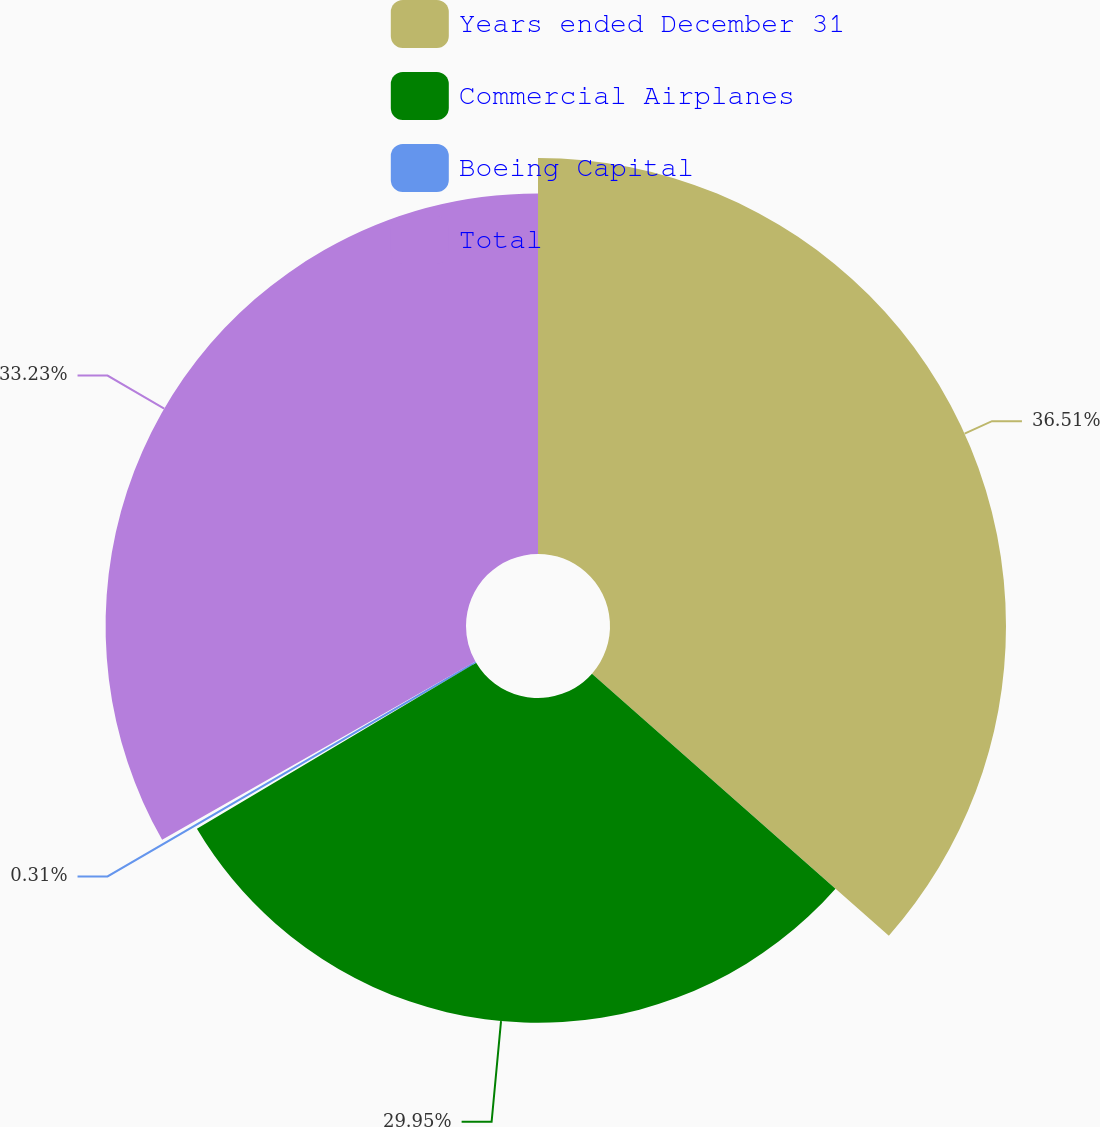Convert chart. <chart><loc_0><loc_0><loc_500><loc_500><pie_chart><fcel>Years ended December 31<fcel>Commercial Airplanes<fcel>Boeing Capital<fcel>Total<nl><fcel>36.51%<fcel>29.95%<fcel>0.31%<fcel>33.23%<nl></chart> 